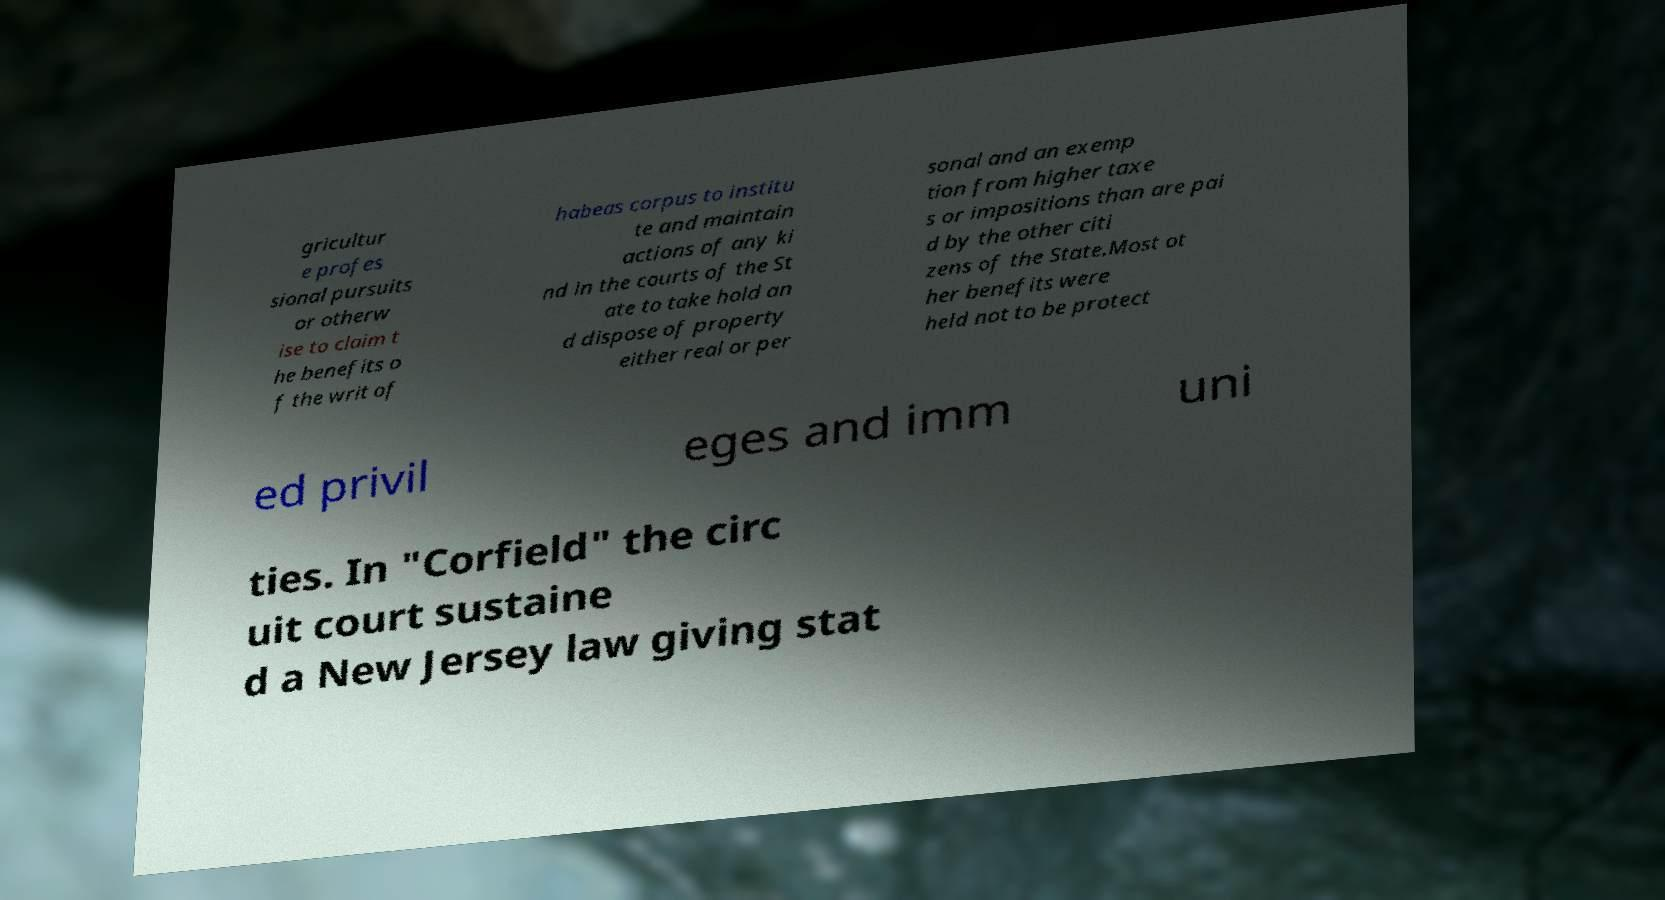What messages or text are displayed in this image? I need them in a readable, typed format. gricultur e profes sional pursuits or otherw ise to claim t he benefits o f the writ of habeas corpus to institu te and maintain actions of any ki nd in the courts of the St ate to take hold an d dispose of property either real or per sonal and an exemp tion from higher taxe s or impositions than are pai d by the other citi zens of the State.Most ot her benefits were held not to be protect ed privil eges and imm uni ties. In "Corfield" the circ uit court sustaine d a New Jersey law giving stat 